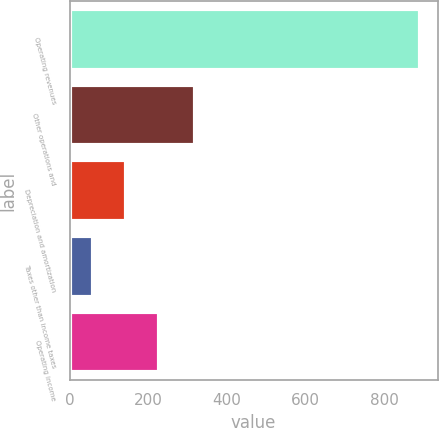<chart> <loc_0><loc_0><loc_500><loc_500><bar_chart><fcel>Operating revenues<fcel>Other operations and<fcel>Depreciation and amortization<fcel>Taxes other than income taxes<fcel>Operating income<nl><fcel>892<fcel>318<fcel>143.2<fcel>60<fcel>226.4<nl></chart> 